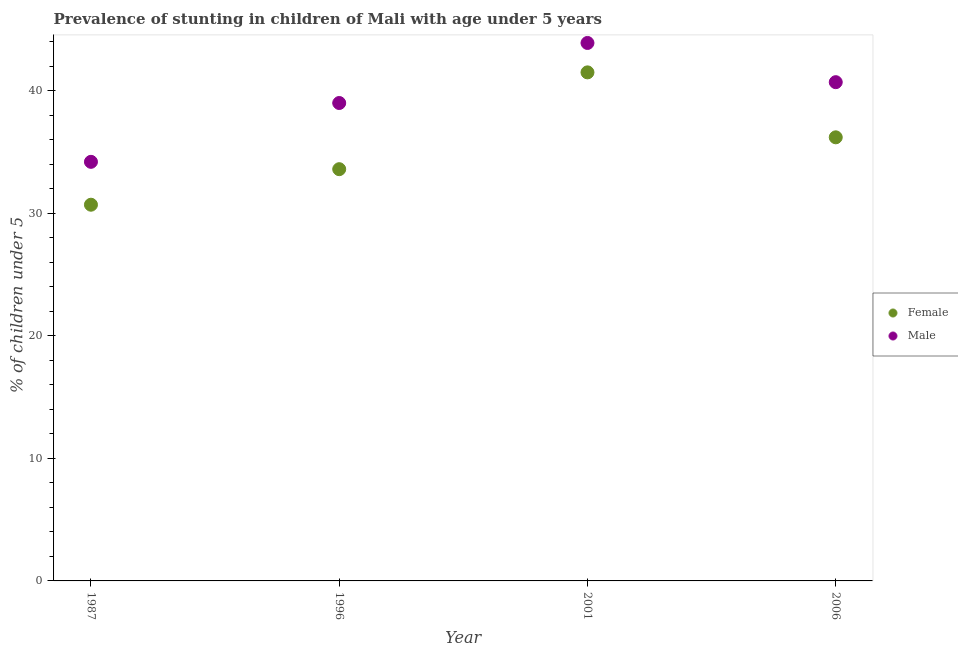Is the number of dotlines equal to the number of legend labels?
Keep it short and to the point. Yes. What is the percentage of stunted female children in 2001?
Offer a terse response. 41.5. Across all years, what is the maximum percentage of stunted male children?
Offer a terse response. 43.9. Across all years, what is the minimum percentage of stunted female children?
Provide a succinct answer. 30.7. In which year was the percentage of stunted female children minimum?
Keep it short and to the point. 1987. What is the total percentage of stunted male children in the graph?
Keep it short and to the point. 157.8. What is the difference between the percentage of stunted female children in 1987 and that in 2006?
Make the answer very short. -5.5. What is the difference between the percentage of stunted male children in 2001 and the percentage of stunted female children in 2006?
Provide a succinct answer. 7.7. What is the average percentage of stunted male children per year?
Offer a terse response. 39.45. In the year 1996, what is the difference between the percentage of stunted male children and percentage of stunted female children?
Your response must be concise. 5.4. In how many years, is the percentage of stunted male children greater than 12 %?
Make the answer very short. 4. What is the ratio of the percentage of stunted female children in 1987 to that in 2006?
Your answer should be compact. 0.85. Is the percentage of stunted female children in 1987 less than that in 1996?
Offer a very short reply. Yes. What is the difference between the highest and the second highest percentage of stunted female children?
Your response must be concise. 5.3. What is the difference between the highest and the lowest percentage of stunted female children?
Make the answer very short. 10.8. Is the sum of the percentage of stunted female children in 2001 and 2006 greater than the maximum percentage of stunted male children across all years?
Your answer should be very brief. Yes. Does the percentage of stunted female children monotonically increase over the years?
Offer a very short reply. No. How many dotlines are there?
Keep it short and to the point. 2. How many years are there in the graph?
Provide a short and direct response. 4. What is the difference between two consecutive major ticks on the Y-axis?
Make the answer very short. 10. Are the values on the major ticks of Y-axis written in scientific E-notation?
Your response must be concise. No. Does the graph contain any zero values?
Your answer should be very brief. No. How many legend labels are there?
Keep it short and to the point. 2. What is the title of the graph?
Ensure brevity in your answer.  Prevalence of stunting in children of Mali with age under 5 years. What is the label or title of the X-axis?
Provide a short and direct response. Year. What is the label or title of the Y-axis?
Provide a succinct answer.  % of children under 5. What is the  % of children under 5 of Female in 1987?
Give a very brief answer. 30.7. What is the  % of children under 5 in Male in 1987?
Provide a succinct answer. 34.2. What is the  % of children under 5 of Female in 1996?
Keep it short and to the point. 33.6. What is the  % of children under 5 in Female in 2001?
Ensure brevity in your answer.  41.5. What is the  % of children under 5 in Male in 2001?
Ensure brevity in your answer.  43.9. What is the  % of children under 5 of Female in 2006?
Provide a succinct answer. 36.2. What is the  % of children under 5 of Male in 2006?
Your answer should be very brief. 40.7. Across all years, what is the maximum  % of children under 5 of Female?
Make the answer very short. 41.5. Across all years, what is the maximum  % of children under 5 in Male?
Your answer should be compact. 43.9. Across all years, what is the minimum  % of children under 5 of Female?
Your answer should be compact. 30.7. Across all years, what is the minimum  % of children under 5 in Male?
Your answer should be very brief. 34.2. What is the total  % of children under 5 in Female in the graph?
Offer a terse response. 142. What is the total  % of children under 5 of Male in the graph?
Your response must be concise. 157.8. What is the difference between the  % of children under 5 in Female in 1987 and that in 1996?
Your answer should be compact. -2.9. What is the difference between the  % of children under 5 in Male in 1987 and that in 2001?
Keep it short and to the point. -9.7. What is the difference between the  % of children under 5 in Female in 1996 and that in 2001?
Give a very brief answer. -7.9. What is the difference between the  % of children under 5 of Male in 1996 and that in 2001?
Provide a succinct answer. -4.9. What is the difference between the  % of children under 5 in Female in 1996 and that in 2006?
Ensure brevity in your answer.  -2.6. What is the difference between the  % of children under 5 of Female in 1987 and the  % of children under 5 of Male in 2001?
Keep it short and to the point. -13.2. What is the difference between the  % of children under 5 in Female in 1996 and the  % of children under 5 in Male in 2001?
Provide a short and direct response. -10.3. What is the average  % of children under 5 in Female per year?
Offer a terse response. 35.5. What is the average  % of children under 5 of Male per year?
Provide a succinct answer. 39.45. In the year 1996, what is the difference between the  % of children under 5 in Female and  % of children under 5 in Male?
Offer a terse response. -5.4. In the year 2006, what is the difference between the  % of children under 5 in Female and  % of children under 5 in Male?
Give a very brief answer. -4.5. What is the ratio of the  % of children under 5 of Female in 1987 to that in 1996?
Give a very brief answer. 0.91. What is the ratio of the  % of children under 5 of Male in 1987 to that in 1996?
Provide a short and direct response. 0.88. What is the ratio of the  % of children under 5 in Female in 1987 to that in 2001?
Offer a terse response. 0.74. What is the ratio of the  % of children under 5 of Male in 1987 to that in 2001?
Ensure brevity in your answer.  0.78. What is the ratio of the  % of children under 5 in Female in 1987 to that in 2006?
Provide a short and direct response. 0.85. What is the ratio of the  % of children under 5 in Male in 1987 to that in 2006?
Your answer should be very brief. 0.84. What is the ratio of the  % of children under 5 of Female in 1996 to that in 2001?
Provide a short and direct response. 0.81. What is the ratio of the  % of children under 5 of Male in 1996 to that in 2001?
Offer a terse response. 0.89. What is the ratio of the  % of children under 5 in Female in 1996 to that in 2006?
Provide a short and direct response. 0.93. What is the ratio of the  % of children under 5 of Male in 1996 to that in 2006?
Offer a terse response. 0.96. What is the ratio of the  % of children under 5 in Female in 2001 to that in 2006?
Offer a terse response. 1.15. What is the ratio of the  % of children under 5 of Male in 2001 to that in 2006?
Offer a very short reply. 1.08. What is the difference between the highest and the second highest  % of children under 5 in Male?
Make the answer very short. 3.2. What is the difference between the highest and the lowest  % of children under 5 in Female?
Provide a short and direct response. 10.8. 